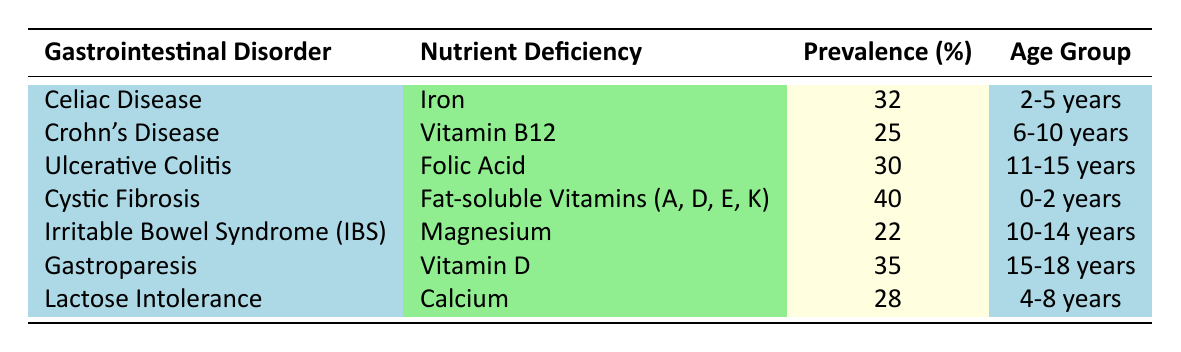What is the nutrient deficiency associated with Cystic Fibrosis? The table clearly states that Cystic Fibrosis is associated with a deficiency in Fat-soluble Vitamins (A, D, E, K).
Answer: Fat-soluble Vitamins (A, D, E, K) What is the prevalence percentage of Iron deficiency in children aged 2-5 years with Celiac Disease? The table shows that for Celiac Disease, the prevalence percentage of Iron deficiency is 32% for the age group 2-5 years.
Answer: 32% Which gastrointestinal disorder has the highest prevalence of nutrient deficiency? Looking at the table, Cystic Fibrosis has the highest prevalence percentage of 40% for Fat-soluble Vitamins (A, D, E, K).
Answer: Cystic Fibrosis Is the prevalence of Vitamin D deficiency higher in Gastroparesis than in Crohn's Disease? The table lists 35% for Gastroparesis (Vitamin D) and 25% for Crohn's Disease (Vitamin B12). Since 35% is greater than 25%, the statement is true.
Answer: Yes What is the average prevalence percentage of nutrient deficiencies for the age group 10-14 years? From the table, the only entries for 10-14 years are Irritable Bowel Syndrome (22%) and Gastroparesis (not listed). The average calculation involves only this single entry, so average = (22%) / 1 = 22%.
Answer: 22% How many nutrient deficiencies have a prevalence of 30% or higher? The table lists Cystic Fibrosis (40%), Gastroparesis (35%), Celiac Disease (32%), and Ulcerative Colitis (30%). There are a total of 4 deficiencies that meet this criterion.
Answer: 4 What nutrient deficiencies are notable for children aged 4-8 years? The table shows that for children aged 4-8 years, the notable nutrient deficiency is Calcium, with a prevalence percentage of 28%.
Answer: Calcium Do children aged 11-15 years with Ulcerative Colitis have a higher prevalence of nutrient deficiency compared to those aged 0-2 years with Cystic Fibrosis? The prevalence for Ulcerative Colitis (30%) is lower than that for Cystic Fibrosis (40%), therefore children with Cystic Fibrosis have a higher prevalence of nutrient deficiency.
Answer: No 